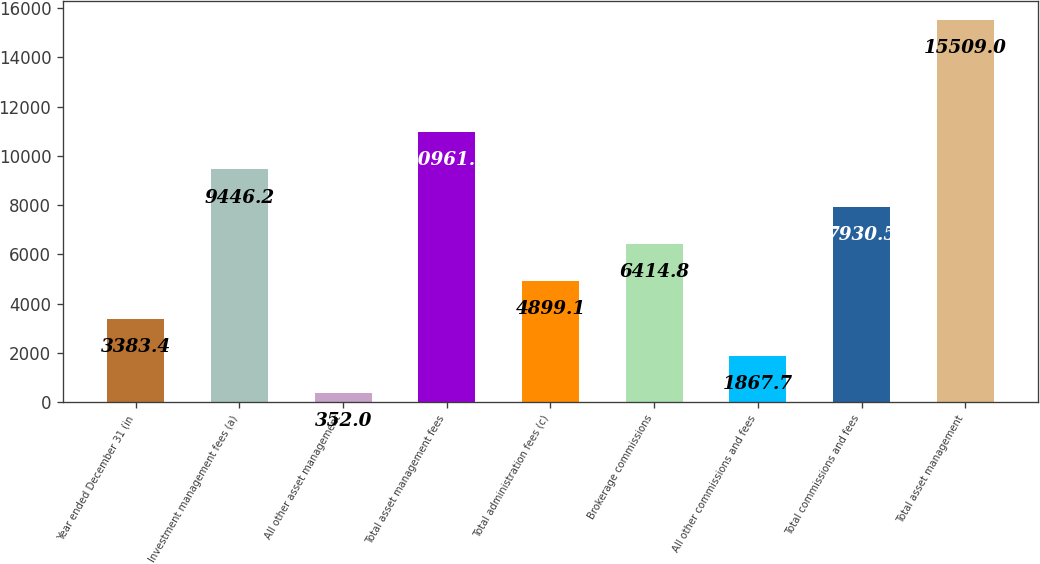Convert chart to OTSL. <chart><loc_0><loc_0><loc_500><loc_500><bar_chart><fcel>Year ended December 31 (in<fcel>Investment management fees (a)<fcel>All other asset management<fcel>Total asset management fees<fcel>Total administration fees (c)<fcel>Brokerage commissions<fcel>All other commissions and fees<fcel>Total commissions and fees<fcel>Total asset management<nl><fcel>3383.4<fcel>9446.2<fcel>352<fcel>10961.9<fcel>4899.1<fcel>6414.8<fcel>1867.7<fcel>7930.5<fcel>15509<nl></chart> 